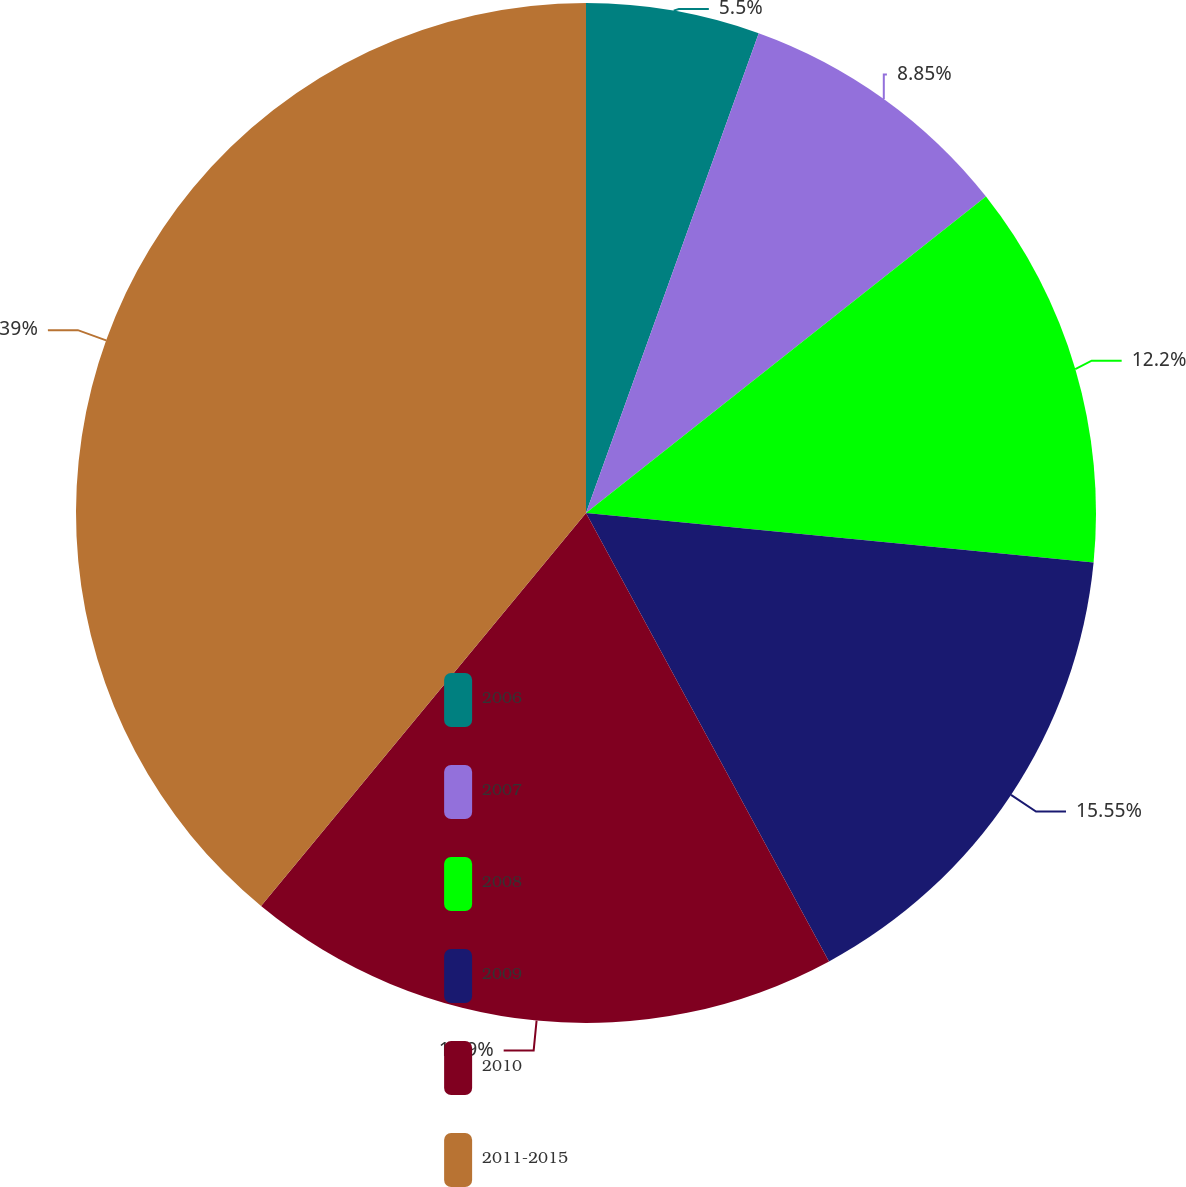Convert chart to OTSL. <chart><loc_0><loc_0><loc_500><loc_500><pie_chart><fcel>2006<fcel>2007<fcel>2008<fcel>2009<fcel>2010<fcel>2011-2015<nl><fcel>5.5%<fcel>8.85%<fcel>12.2%<fcel>15.55%<fcel>18.9%<fcel>39.01%<nl></chart> 